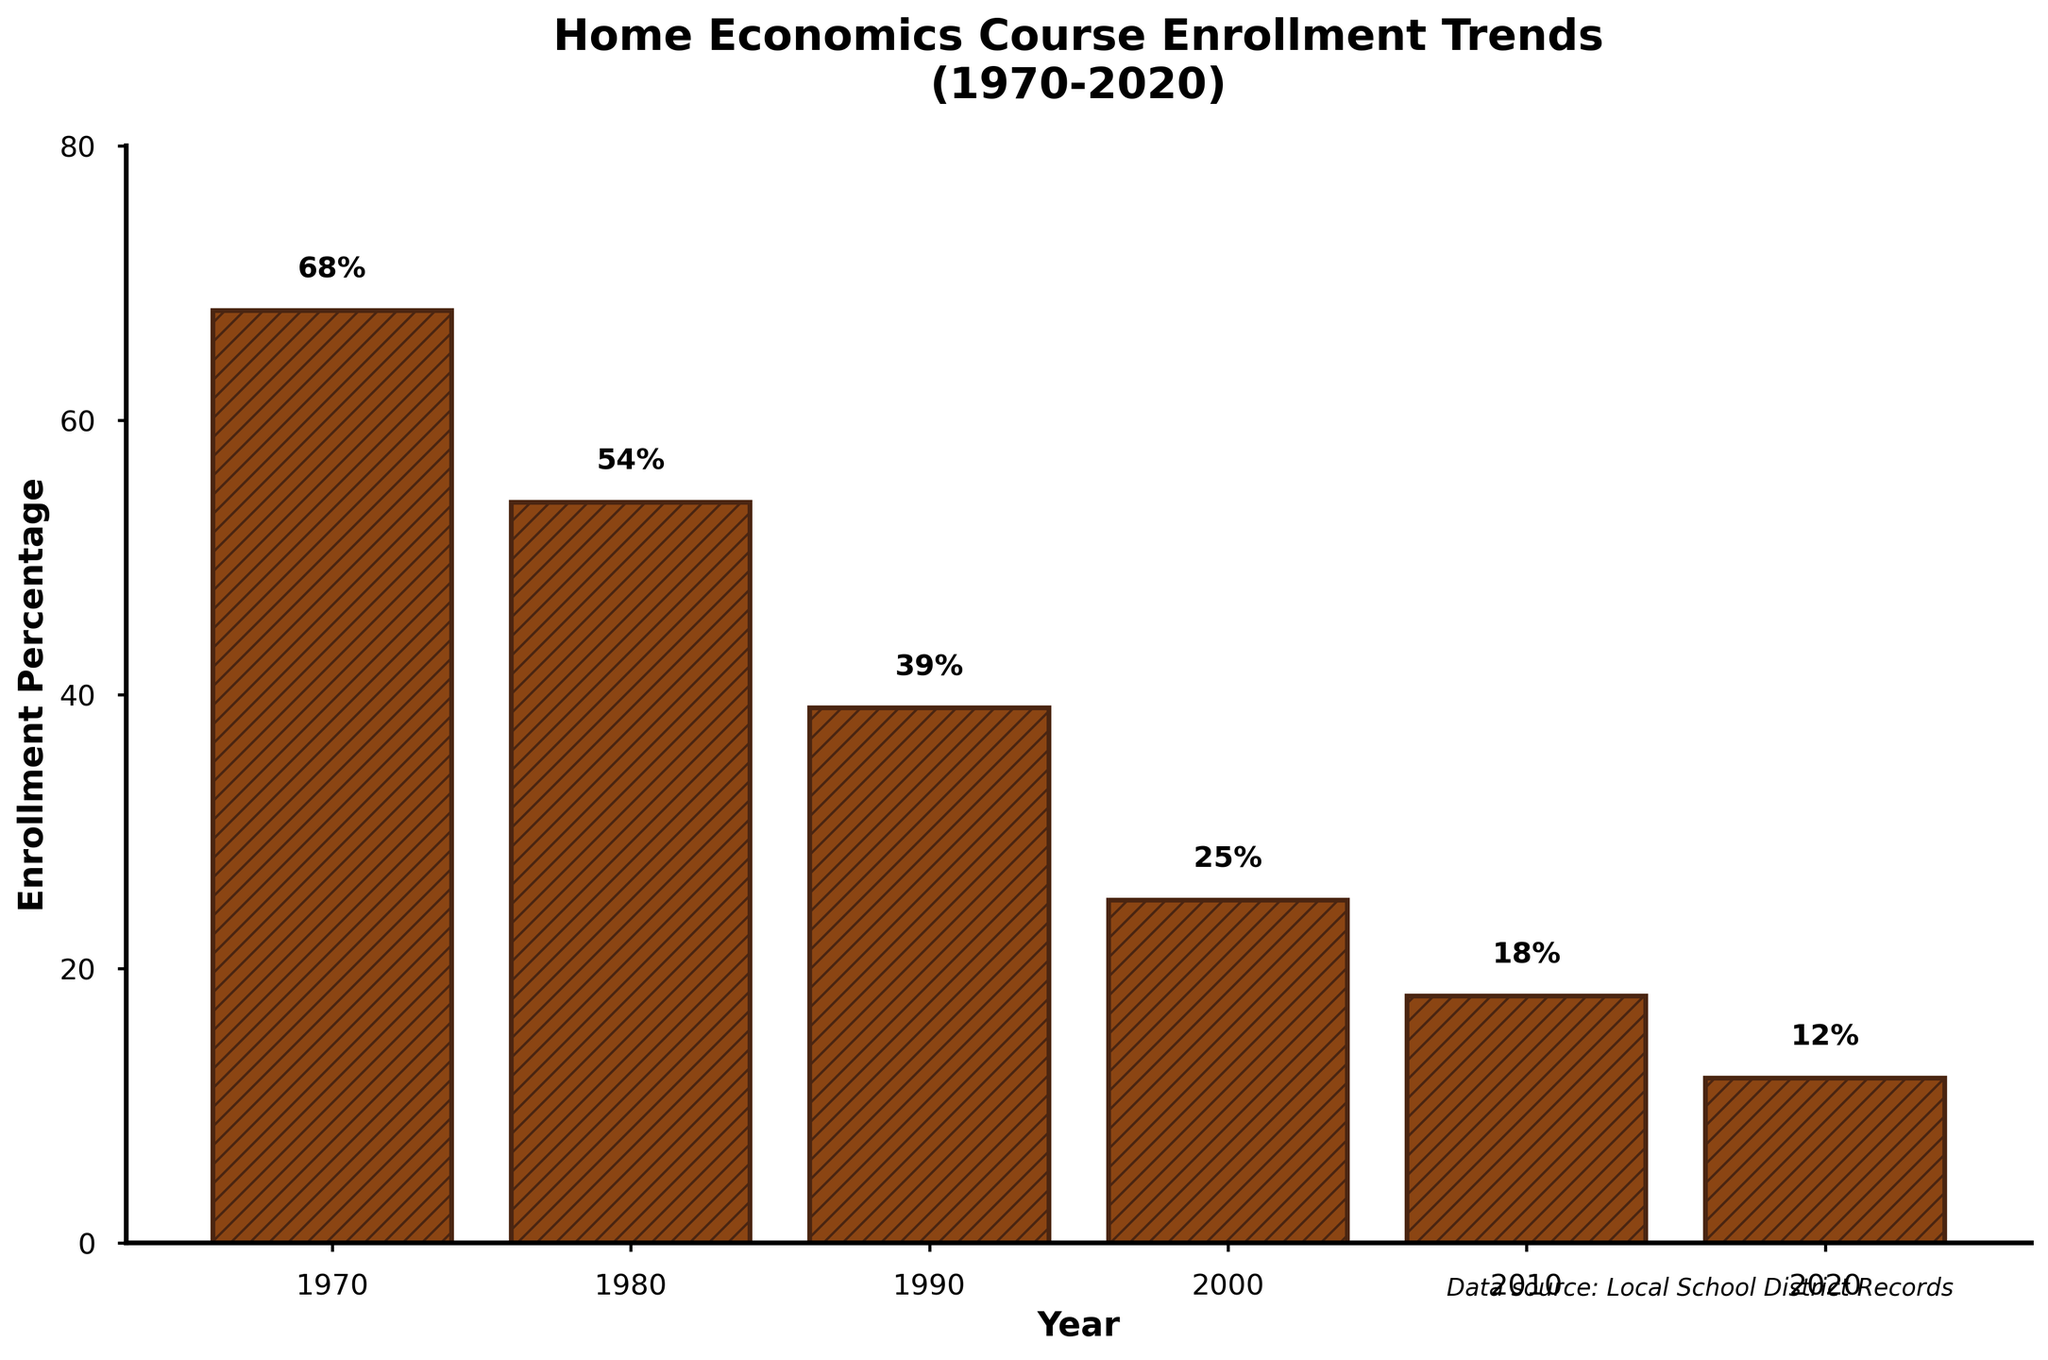How has the enrollment percentage changed from 1970 to 2020? To find the change in enrollment percentage from 1970 to 2020, subtract the enrollment percentage of 2020 from that of 1970 (68% - 12%).
Answer: 56% In which year was the enrollment percentage the highest? By examining the heights of the bars, the tallest bar represents the year with the highest enrollment percentage. The tallest bar is for the year 1970.
Answer: 1970 Which decade saw the largest drop in enrollment percentage? By comparing the differences in enrollment percentage between consecutive decades, we find that the largest drop occurred between 1970 and 1980 (68% - 54% = 14%).
Answer: 1970-1980 What was the average enrollment percentage over the entire period from 1970 to 2020? Add the enrollment percentage for each year, then divide by the number of years ((68 + 54 + 39 + 25 + 18 + 12) / 6).
Answer: 36% Between which consecutive decades did the smallest drop occur? Compare the differences between each pair of consecutive decades: 1970-1980 (14%), 1980-1990 (15%), 1990-2000 (14%), 2000-2010 (7%), and 2010-2020 (6%). The smallest drop occurred between 2010 and 2020.
Answer: 2010-2020 How did the enrollment percentage change from 1980 to 2000? Subtract the enrollment percentage in 2000 from that in 1980 (54% - 25%). The enrollment percentage dropped by 29 percentage points.
Answer: 29% Which year had an enrollment percentage of 18%? Locate the bar that corresponds to the enrollment percentage of 18%, which is labeled 2010.
Answer: 2010 What is the difference in the enrollment percentage between the highest and lowest points? Subtract the smallest enrollment percentage (12% in 2020) from the largest (68% in 1970).
Answer: 56% Describe the visual appearance of the bars for the years 1970 and 2020. The bar for 1970 is the tallest, filled with a brown color and has a hatch pattern of diagonal lines. The bar for 2020 is the shortest, with the same color and pattern but significantly shorter in height.
Answer: Tallest/Shortest What trend can be observed from the enrollment percentages over the past 50 years? The enrollment percentages consistently decreased over the years from 1970 to 2020, indicating a declining trend in the number of students taking home economics courses.
Answer: Decreasing trend 